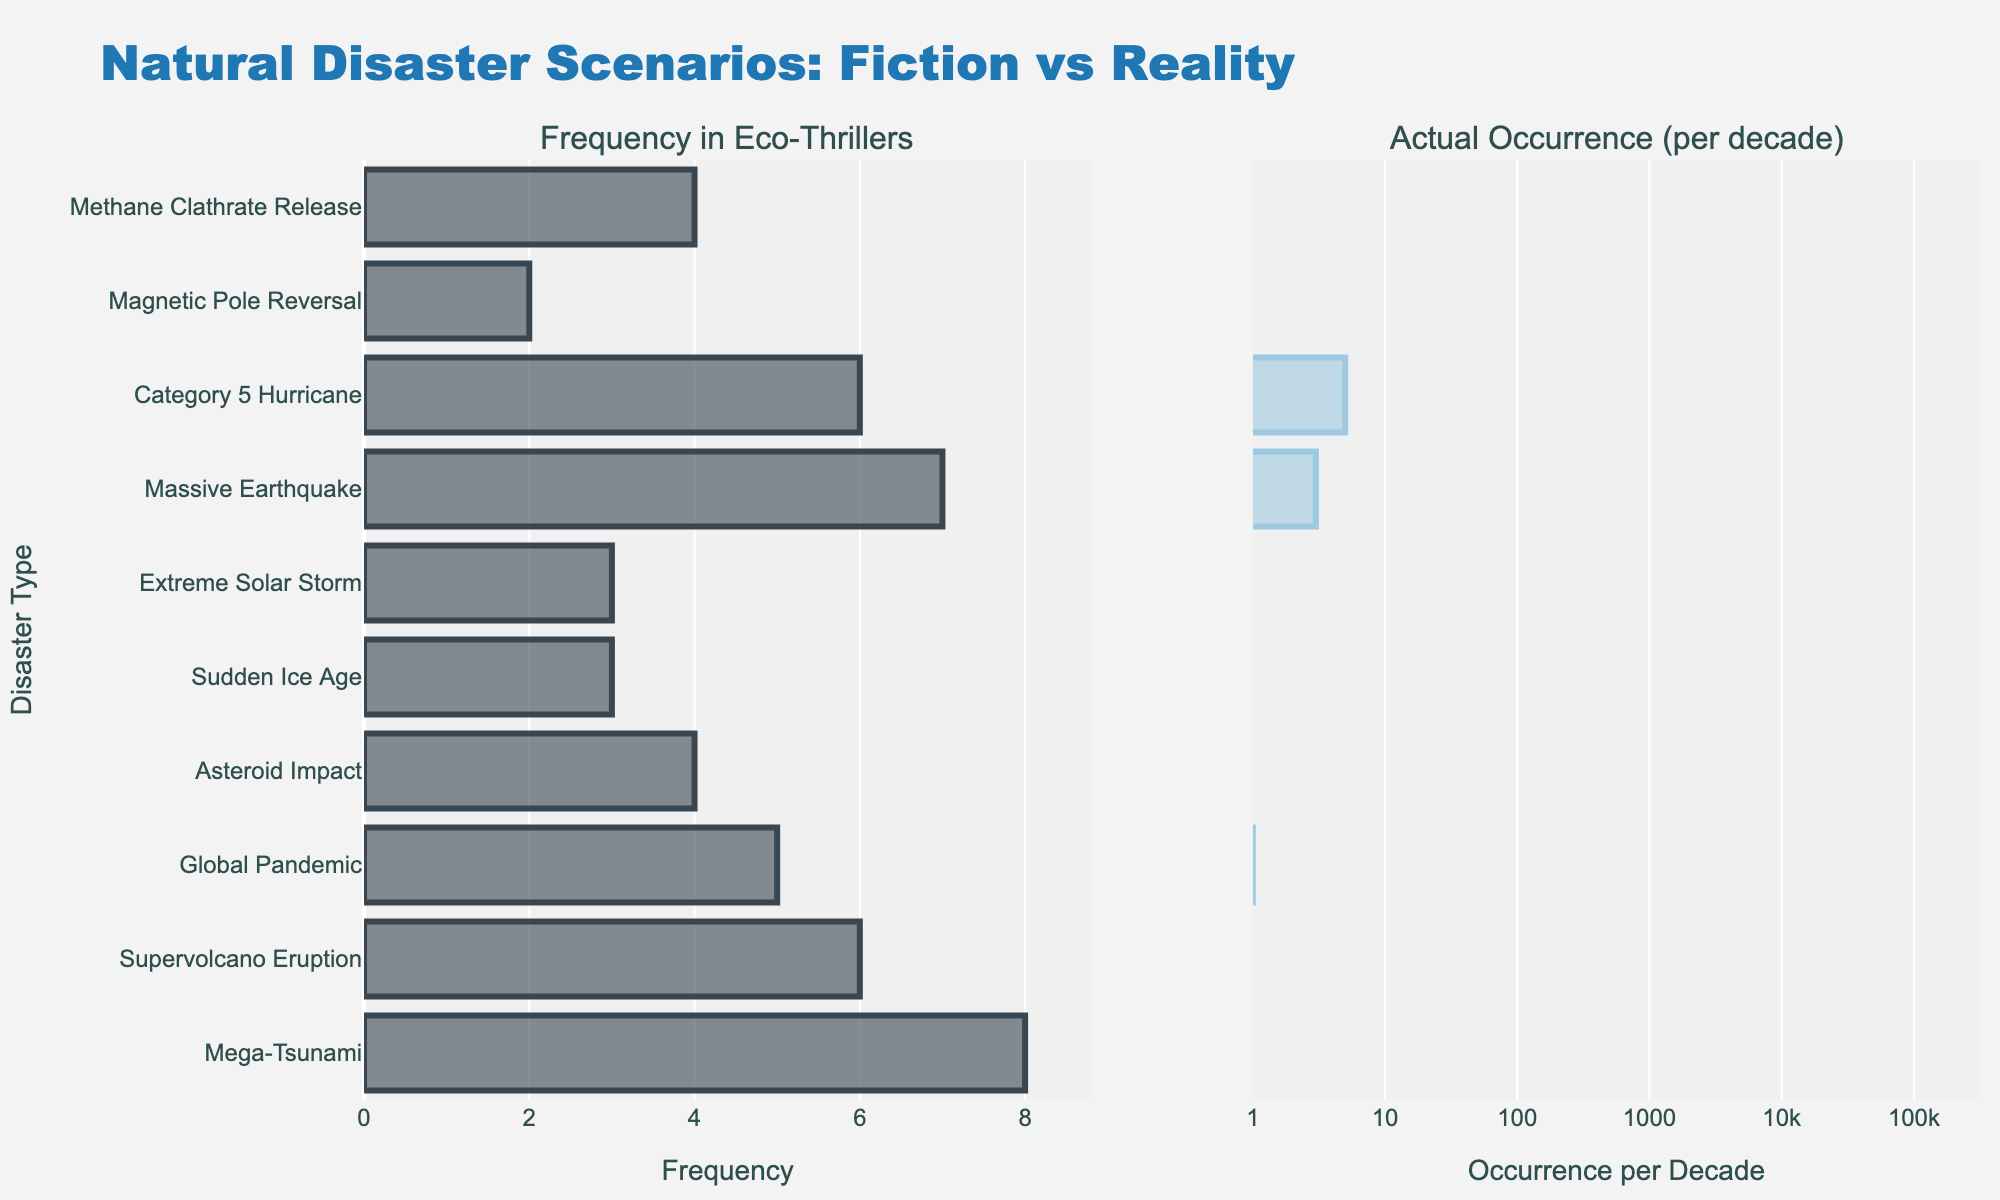What is the title of the figure? The title of the figure is located at the top and provides a summary of what the plot is about.
Answer: Sensory Triggers in Virtual Reality Environments Which sensory type has the highest intensity trigger? Look at the highest bar across all the subplots and identify the sensory type.
Answer: Vestibular What is the intensity level of the "Constant Background Noise" trigger? Find the "Constant Background Noise" trigger in the auditory subplot and note the intensity value written at the end of the bar.
Answer: 6 Compare the intensity of "Virtual Heights" and "Simulated Falling." Which one is higher? Identify the "Virtual Heights" and "Simulated Falling" bars in the vestibular subplot and compare their lengths and the intensity values.
Answer: Virtual Heights How many triggers have an intensity level of 8 or higher? Count all bars in the subplots that have intensity values of 8 or above.
Answer: 4 What is the average intensity of the triggers under the visual sensory type? Add the intensities of all triggers under the visual sensory type and divide by the number of triggers. (9 + 7 + 6 + 5) / 4 = 27 / 4 = 6.75
Answer: 6.75 Which sensory type has the largest variation in trigger intensities? Look at the range between the highest and lowest intensity values for each sensory type and compare them.
Answer: Tactile How does the intensity of "Echoing Effects" compare to the average intensity of all auditory triggers? First, calculate the average intensity for auditory triggers: (8 + 7 + 6 + 5) / 4 = 6.5. Then compare it with the intensity of "Echoing Effects" which is 5.
Answer: Below average Are there more auditory triggers with an intensity level of 6 or greater compared to visual triggers? Count the number of auditory triggers with intensities of 6 or greater and do the same for visual triggers, then compare the counts.
Answer: No 